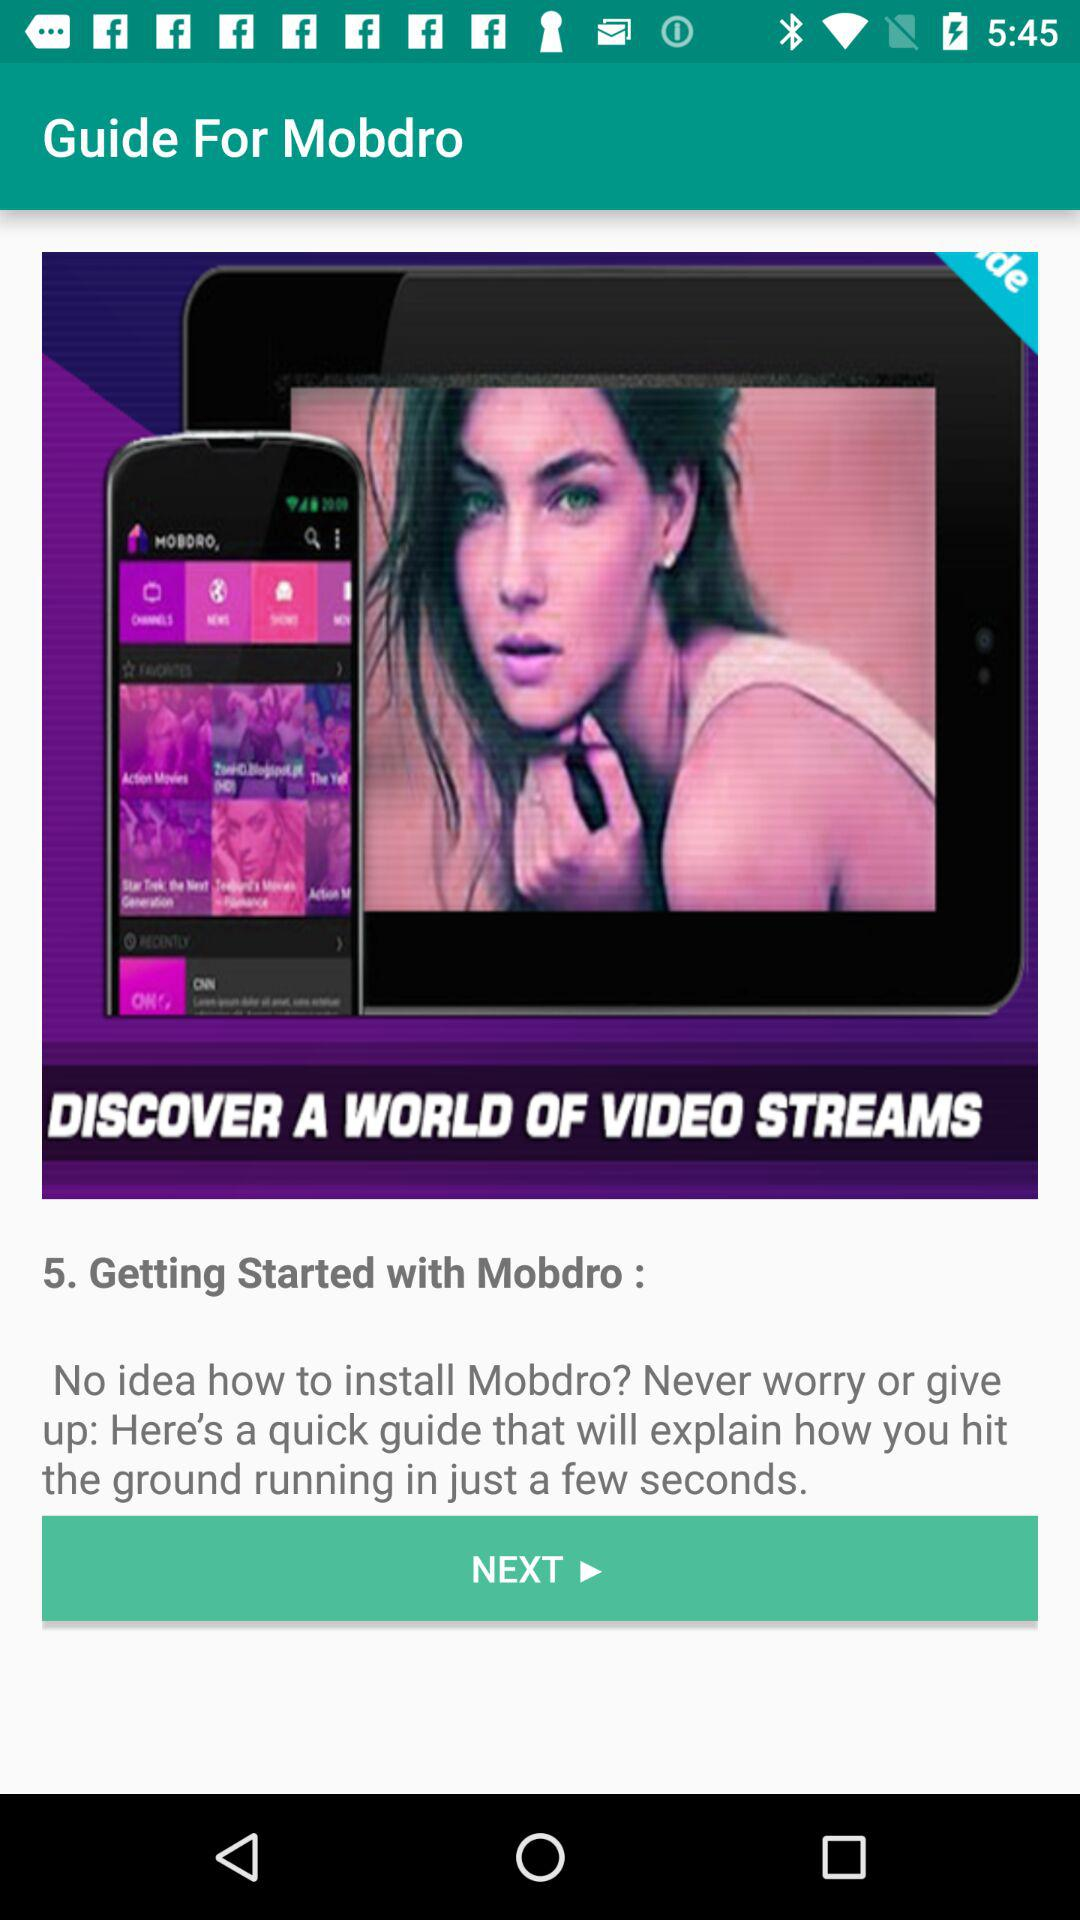What is the application name? The application name is "Mobdro". 